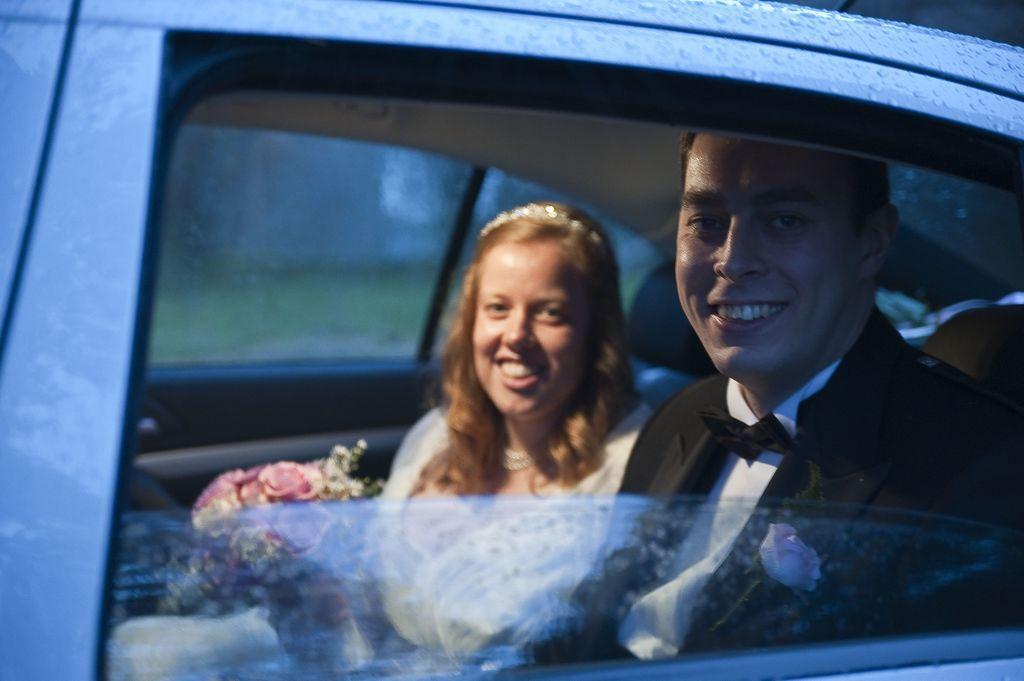Describe this image in one or two sentences. In this picture we can see men and woman sitting inside the car and they are smiling and here man wore blazer, bow tie and for blazer we have a flower and beside to his woman holding flowers in her hand. 